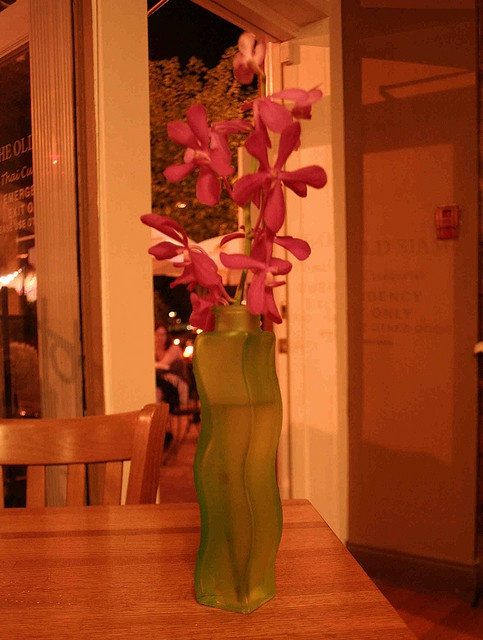Describe the objects in this image and their specific colors. I can see dining table in black, brown, red, and maroon tones, vase in black, brown, and maroon tones, chair in black, brown, maroon, and red tones, dining table in black, brown, red, and salmon tones, and chair in black, maroon, and brown tones in this image. 